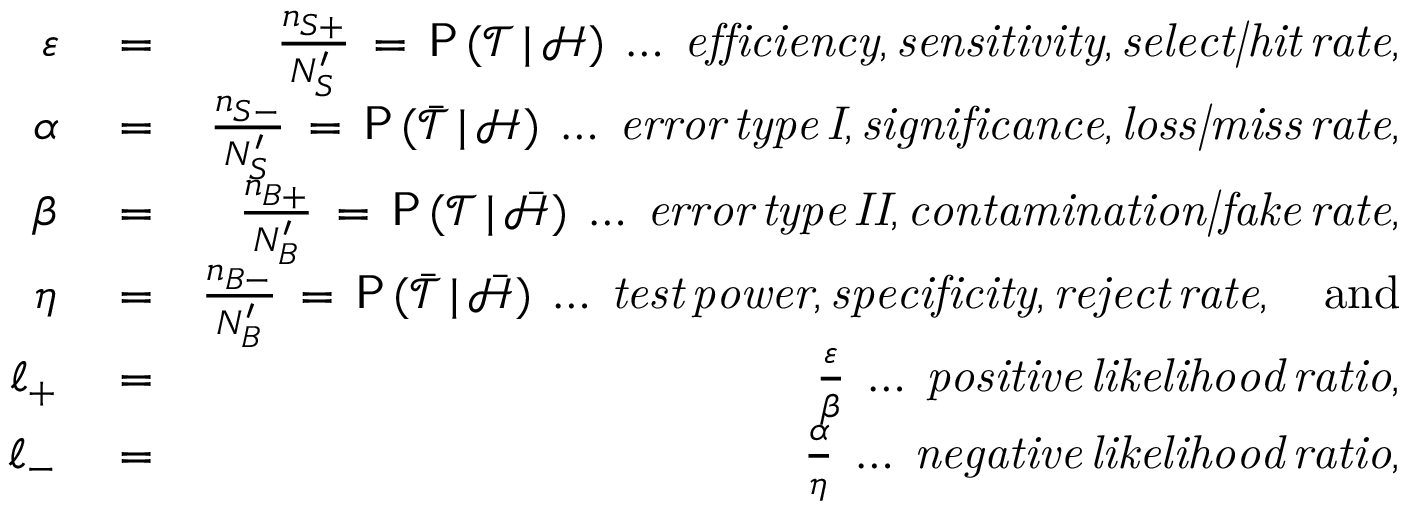Convert formula to latex. <formula><loc_0><loc_0><loc_500><loc_500>\begin{array} { r l r } { \varepsilon } & = } & { \frac { n _ { S + } } { N _ { S } ^ { \prime } } \, = \, P \, ( \mathcal { T } \, | \, \mathcal { H } ) \, \dots \, e f f i c i e n c y , s e n s i t i v i t y , s e l e c t | h i t \, r a t e , } \\ { \alpha } & = } & { \frac { n _ { S - } } { N _ { S } ^ { \prime } } \, = \, P \, ( \bar { \mathcal { T } } \, | \, \mathcal { H } ) \, \dots \, e r r o r \, t y p e \, I , s i g n i f i c a n c e , l o s s | m i s s \, r a t e , } \\ { \beta } & = } & { \frac { n _ { B + } } { N _ { B } ^ { \prime } } \, = \, P \, ( \mathcal { T } \, | \, \bar { \mathcal { H } } ) \, \dots \, e r r o r \, t y p e \, I I , c o n t a \min a t i o n | f a k e \, r a t e , } \\ { \eta } & = } & { \frac { n _ { B - } } { N _ { B } ^ { \prime } } \, = \, P \, ( \bar { \mathcal { T } } \, | \, \bar { \mathcal { H } } ) \, \dots \, t e s t \, p o w e r , s p e c i f i c i t y , r e j e c t \, r a t e , \quad a n d } \\ { \ell _ { + } } & = } & { \frac { \varepsilon } { \beta } \, \dots \, p o s i t i v e \, l i k e l i h o o d \, r a t i o , } \\ { \ell _ { - } } & = } & { \frac { \alpha } { \eta } \, \dots \, n e g a t i v e \, l i k e l i h o o d \, r a t i o , } \end{array}</formula> 